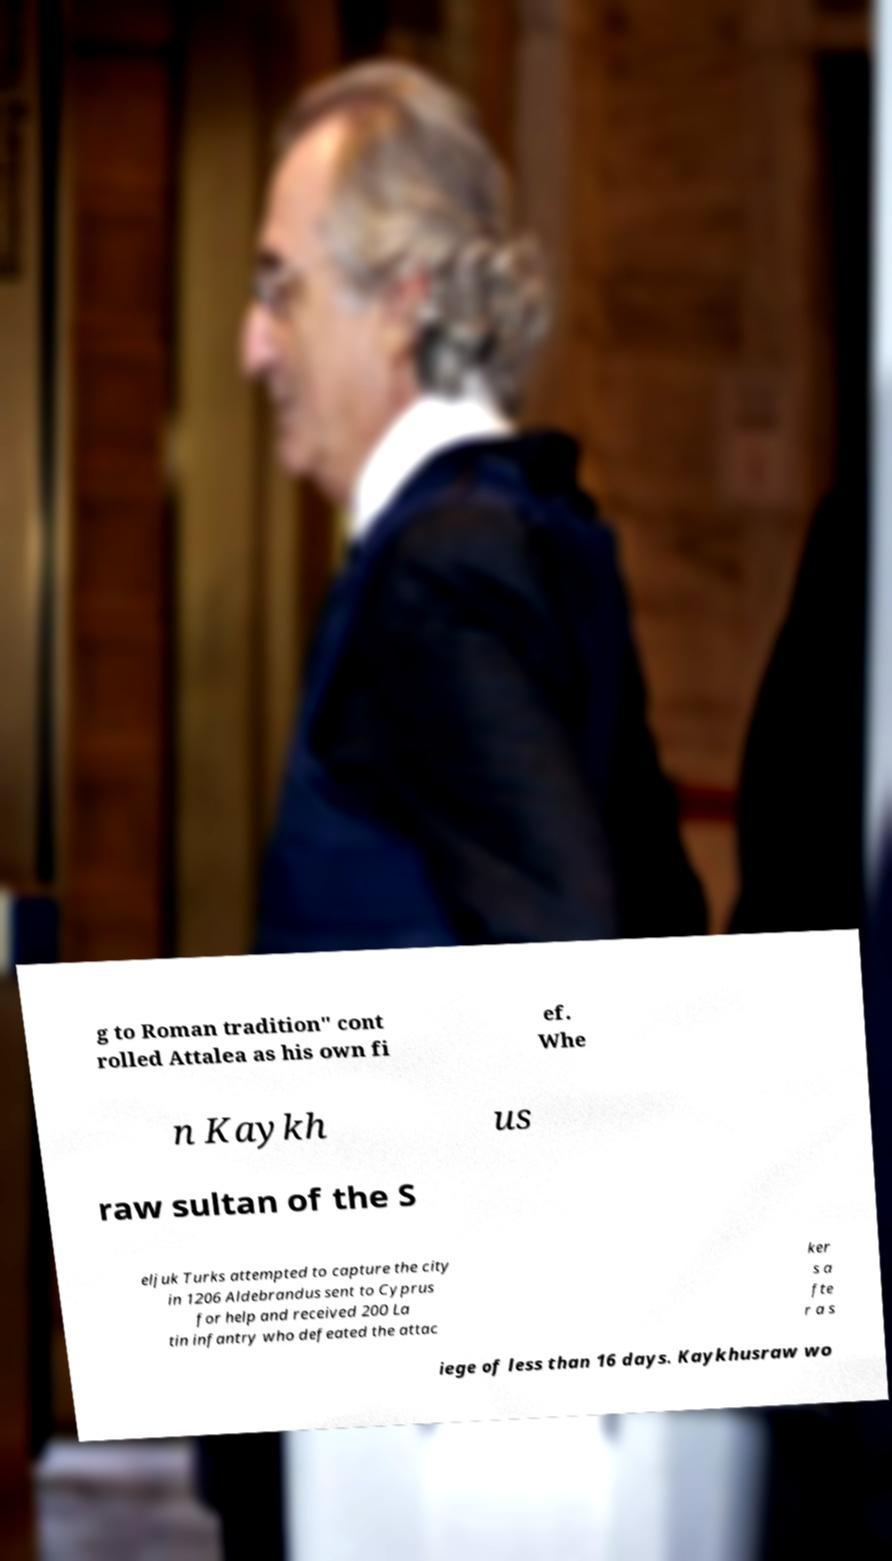There's text embedded in this image that I need extracted. Can you transcribe it verbatim? g to Roman tradition" cont rolled Attalea as his own fi ef. Whe n Kaykh us raw sultan of the S eljuk Turks attempted to capture the city in 1206 Aldebrandus sent to Cyprus for help and received 200 La tin infantry who defeated the attac ker s a fte r a s iege of less than 16 days. Kaykhusraw wo 